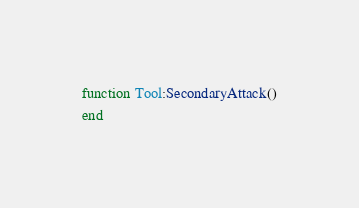Convert code to text. <code><loc_0><loc_0><loc_500><loc_500><_Lua_>
function Tool:SecondaryAttack()
end
</code> 